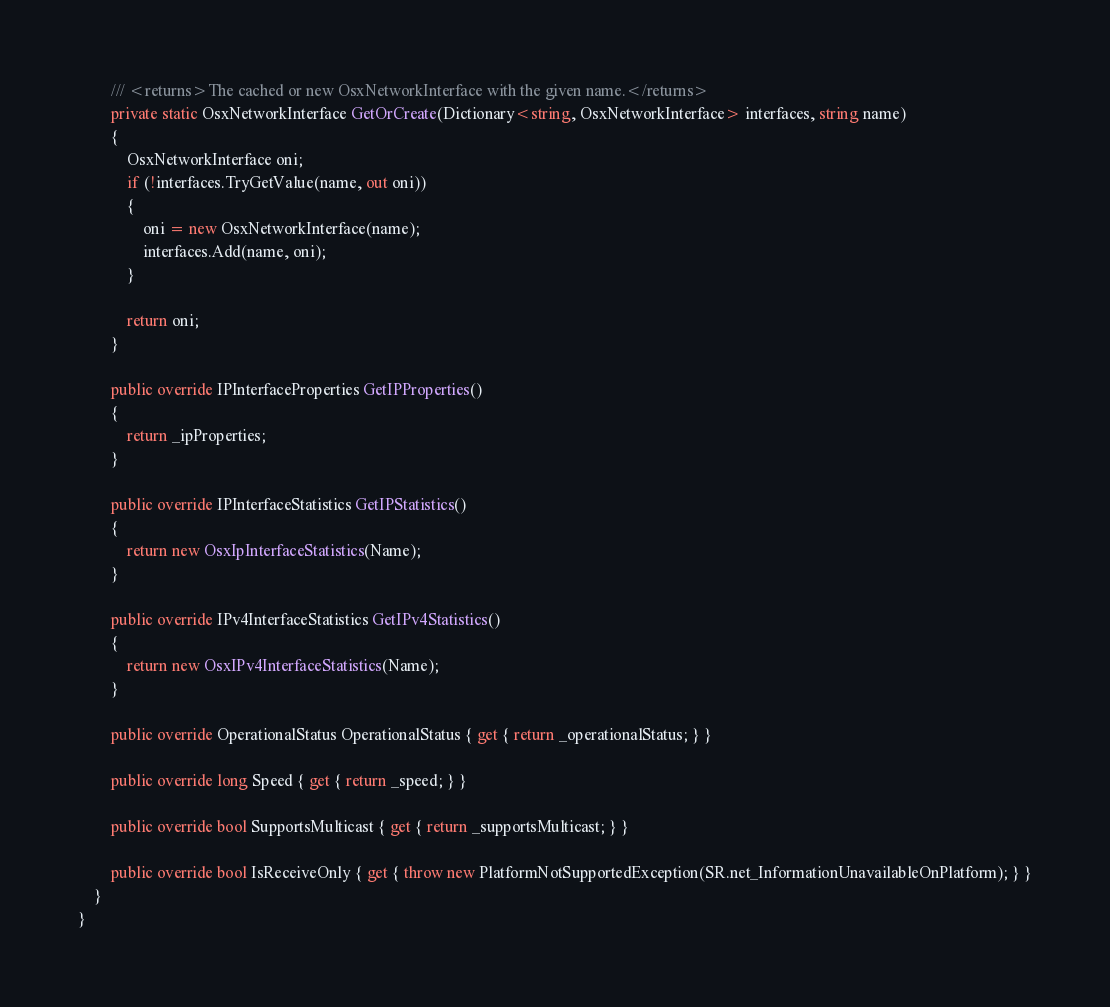Convert code to text. <code><loc_0><loc_0><loc_500><loc_500><_C#_>        /// <returns>The cached or new OsxNetworkInterface with the given name.</returns>
        private static OsxNetworkInterface GetOrCreate(Dictionary<string, OsxNetworkInterface> interfaces, string name)
        {
            OsxNetworkInterface oni;
            if (!interfaces.TryGetValue(name, out oni))
            {
                oni = new OsxNetworkInterface(name);
                interfaces.Add(name, oni);
            }

            return oni;
        }

        public override IPInterfaceProperties GetIPProperties()
        {
            return _ipProperties;
        }

        public override IPInterfaceStatistics GetIPStatistics()
        {
            return new OsxIpInterfaceStatistics(Name);
        }

        public override IPv4InterfaceStatistics GetIPv4Statistics()
        {
            return new OsxIPv4InterfaceStatistics(Name);
        }

        public override OperationalStatus OperationalStatus { get { return _operationalStatus; } }

        public override long Speed { get { return _speed; } }

        public override bool SupportsMulticast { get { return _supportsMulticast; } }

        public override bool IsReceiveOnly { get { throw new PlatformNotSupportedException(SR.net_InformationUnavailableOnPlatform); } }
    }
}
</code> 